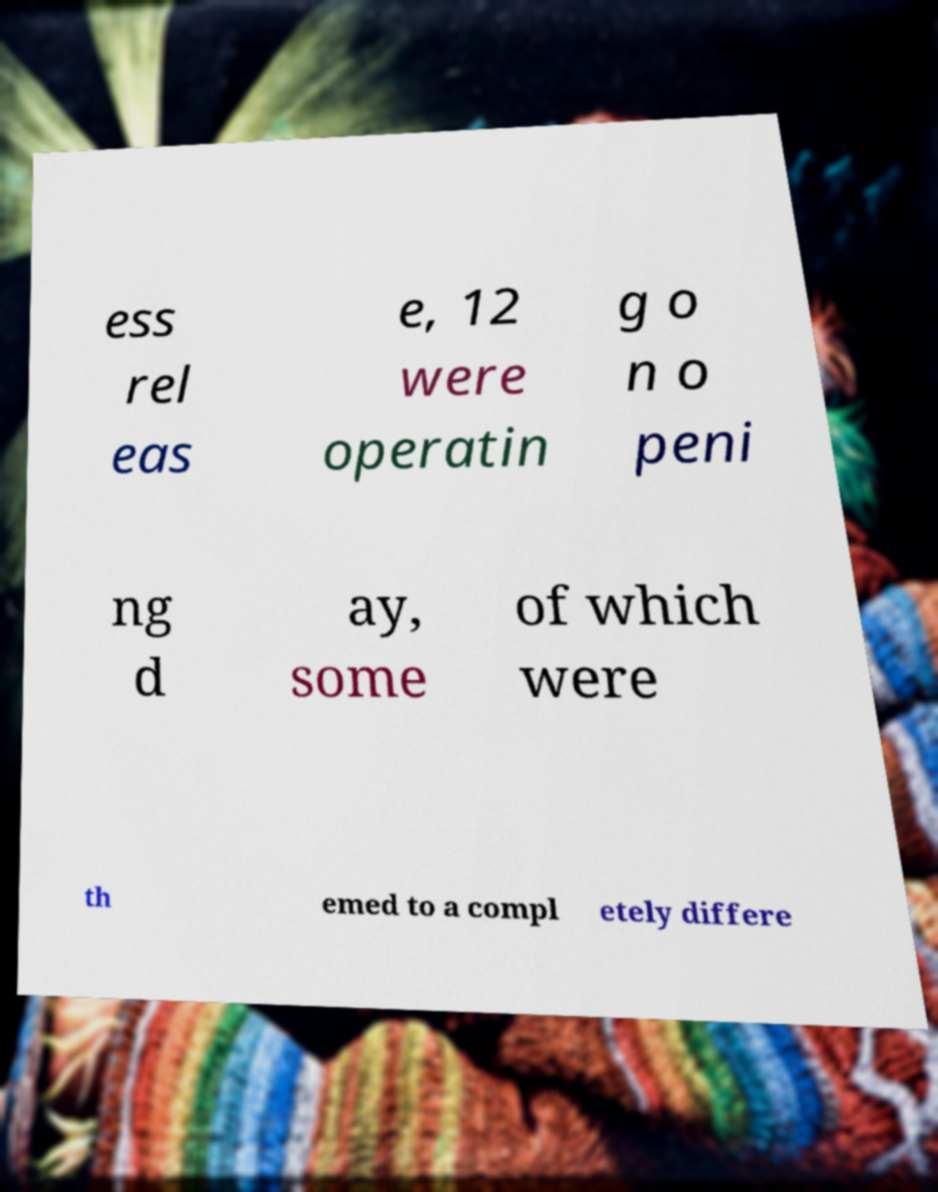Can you accurately transcribe the text from the provided image for me? ess rel eas e, 12 were operatin g o n o peni ng d ay, some of which were th emed to a compl etely differe 